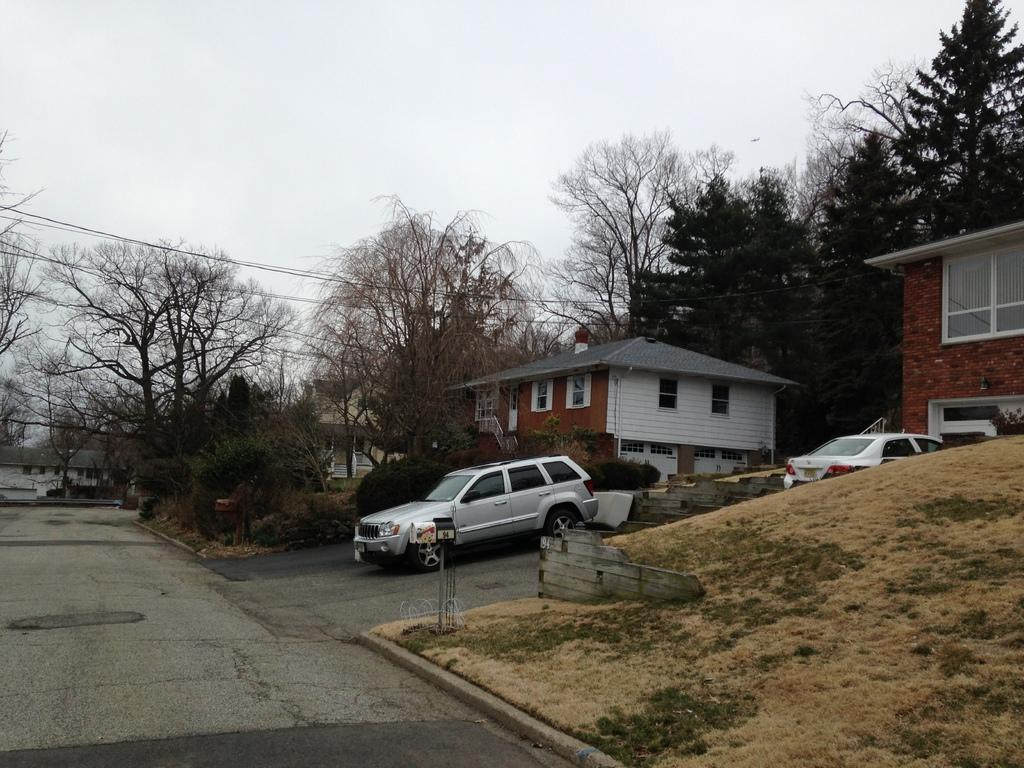What type of structures can be seen in the image? There are buildings in the image. What type of vegetation is present in the image? There are trees and plants in the image. What type of transportation is visible on the road in the image? There are vehicles on the road in the image. What is visible at the top of the image? The sky is visible at the top of the image. How many kittens are playing with balls in the image? There are no kittens or balls present in the image. What fact can be learned about the image from the provided facts? The provided facts do not contain any additional information beyond what is already stated in the conversation. 